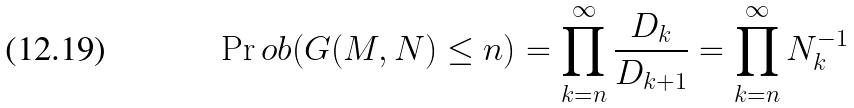Convert formula to latex. <formula><loc_0><loc_0><loc_500><loc_500>\Pr o b ( G ( M , N ) \leq n ) = \prod _ { k = n } ^ { \infty } \frac { D _ { k } } { D _ { k + 1 } } = \prod _ { k = n } ^ { \infty } N _ { k } ^ { - 1 }</formula> 